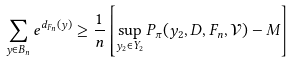<formula> <loc_0><loc_0><loc_500><loc_500>\sum _ { y \in B _ { n } } e ^ { d _ { F _ { n } } ( y ) } \geq \frac { 1 } { n } \left [ \sup _ { y _ { 2 } \in Y _ { 2 } } P _ { \pi } ( y _ { 2 } , D , F _ { n } , \mathcal { V } ) - M \right ]</formula> 